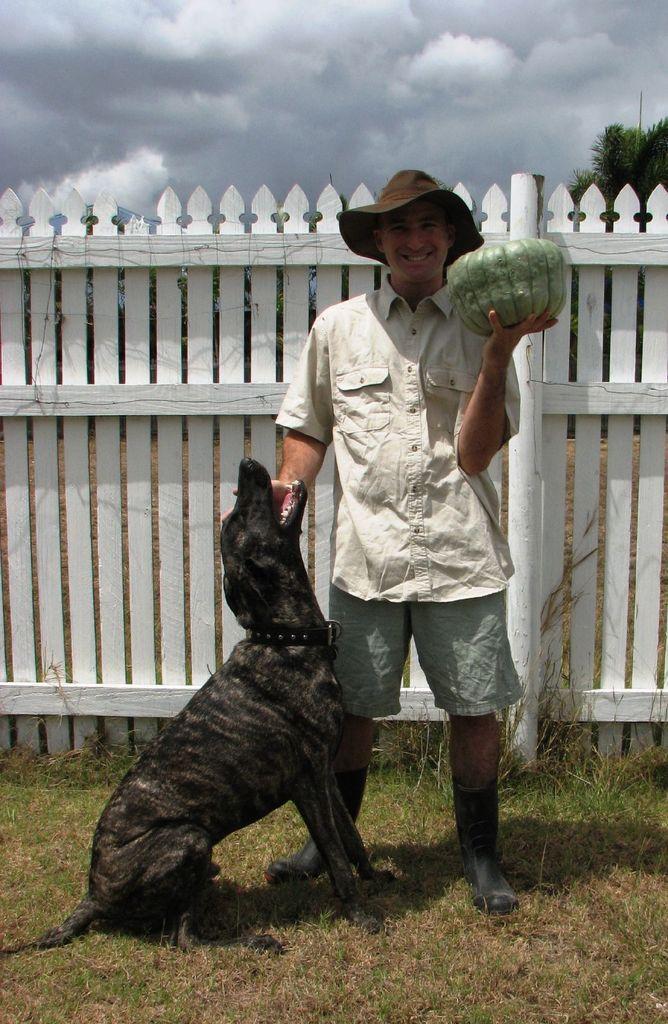Please provide a concise description of this image. This person is smiling, wore cap and in his hand there is a vegetable. In-front of this person there is a dog. Land is covered with grass. Backside of this person there is a fence, sky and tree. Sky is cloudy. 